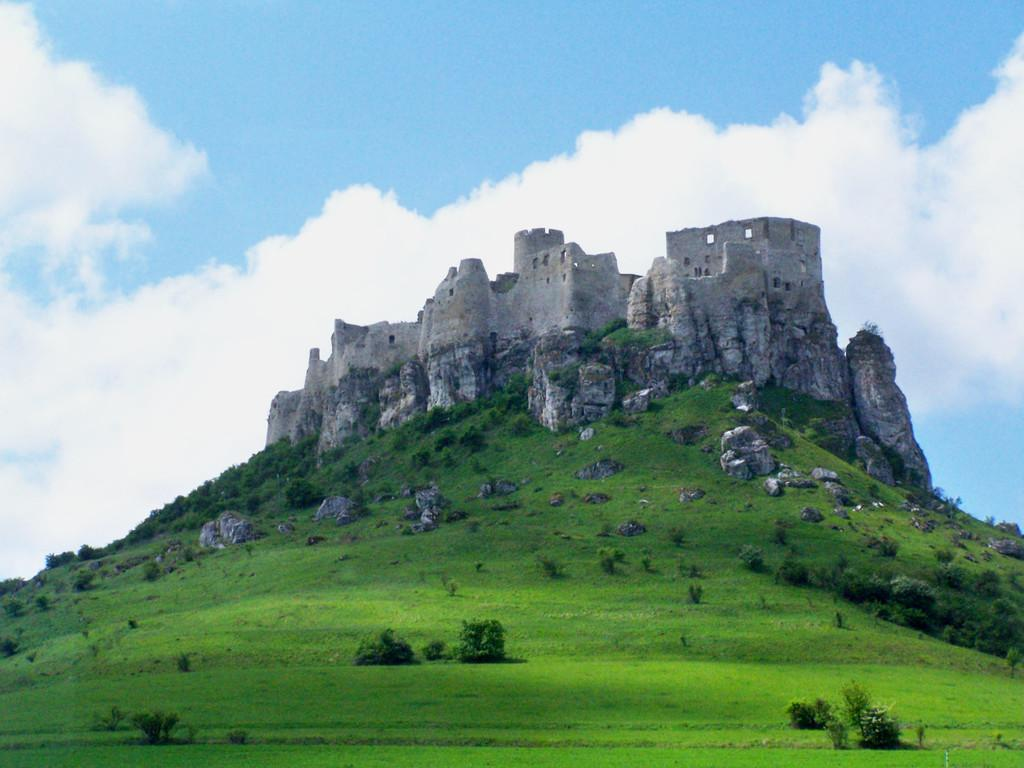What type of structure is visible in the image? There is a fort in the image. What type of vegetation can be seen in the image? There are trees in the image. What colors are present in the sky in the image? The sky is blue and white in color. Where is the guide located in the image? There is no guide present in the image. What type of structure is the scarecrow standing in front of in the image? There is no scarecrow present in the image. 